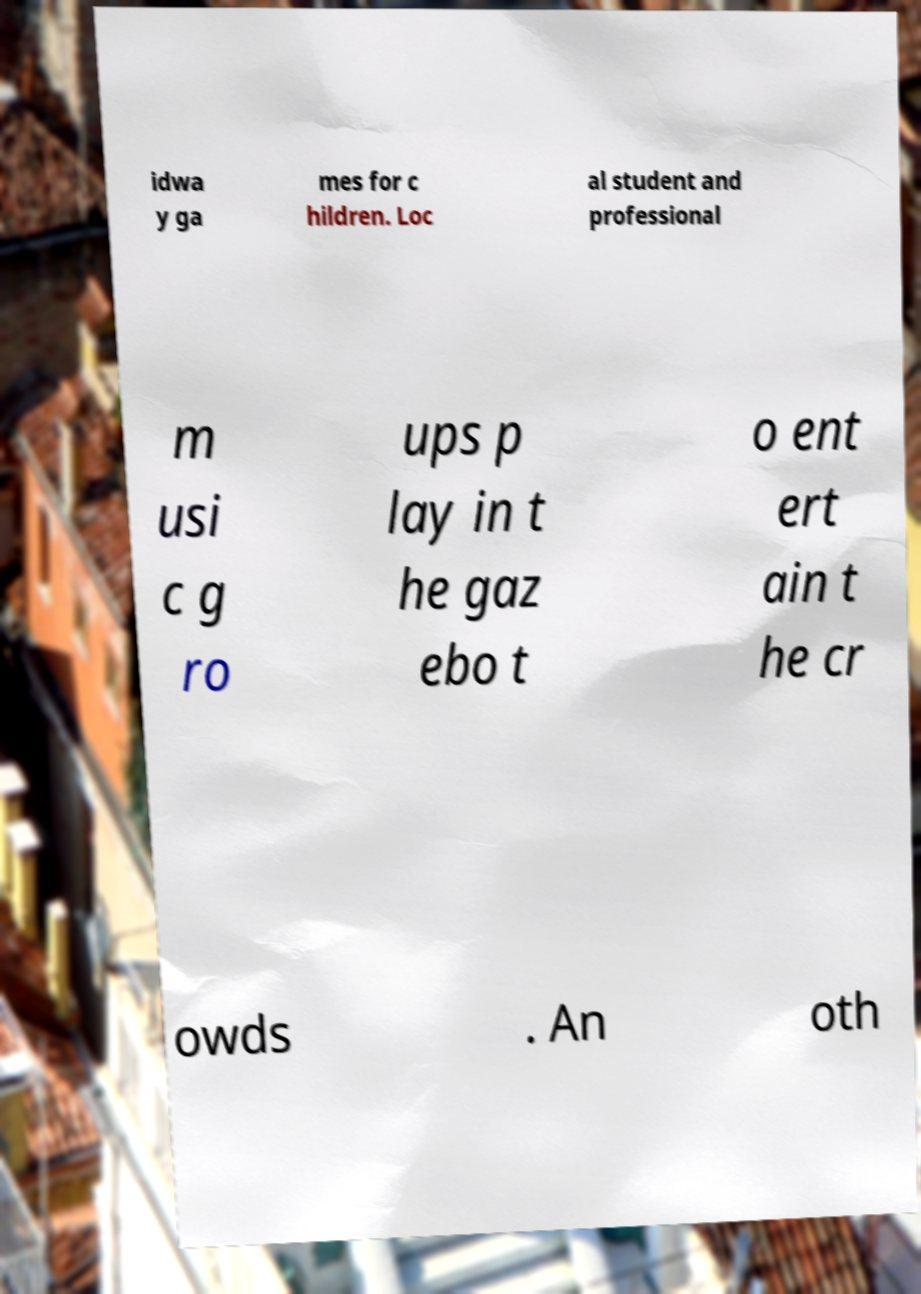Could you assist in decoding the text presented in this image and type it out clearly? idwa y ga mes for c hildren. Loc al student and professional m usi c g ro ups p lay in t he gaz ebo t o ent ert ain t he cr owds . An oth 